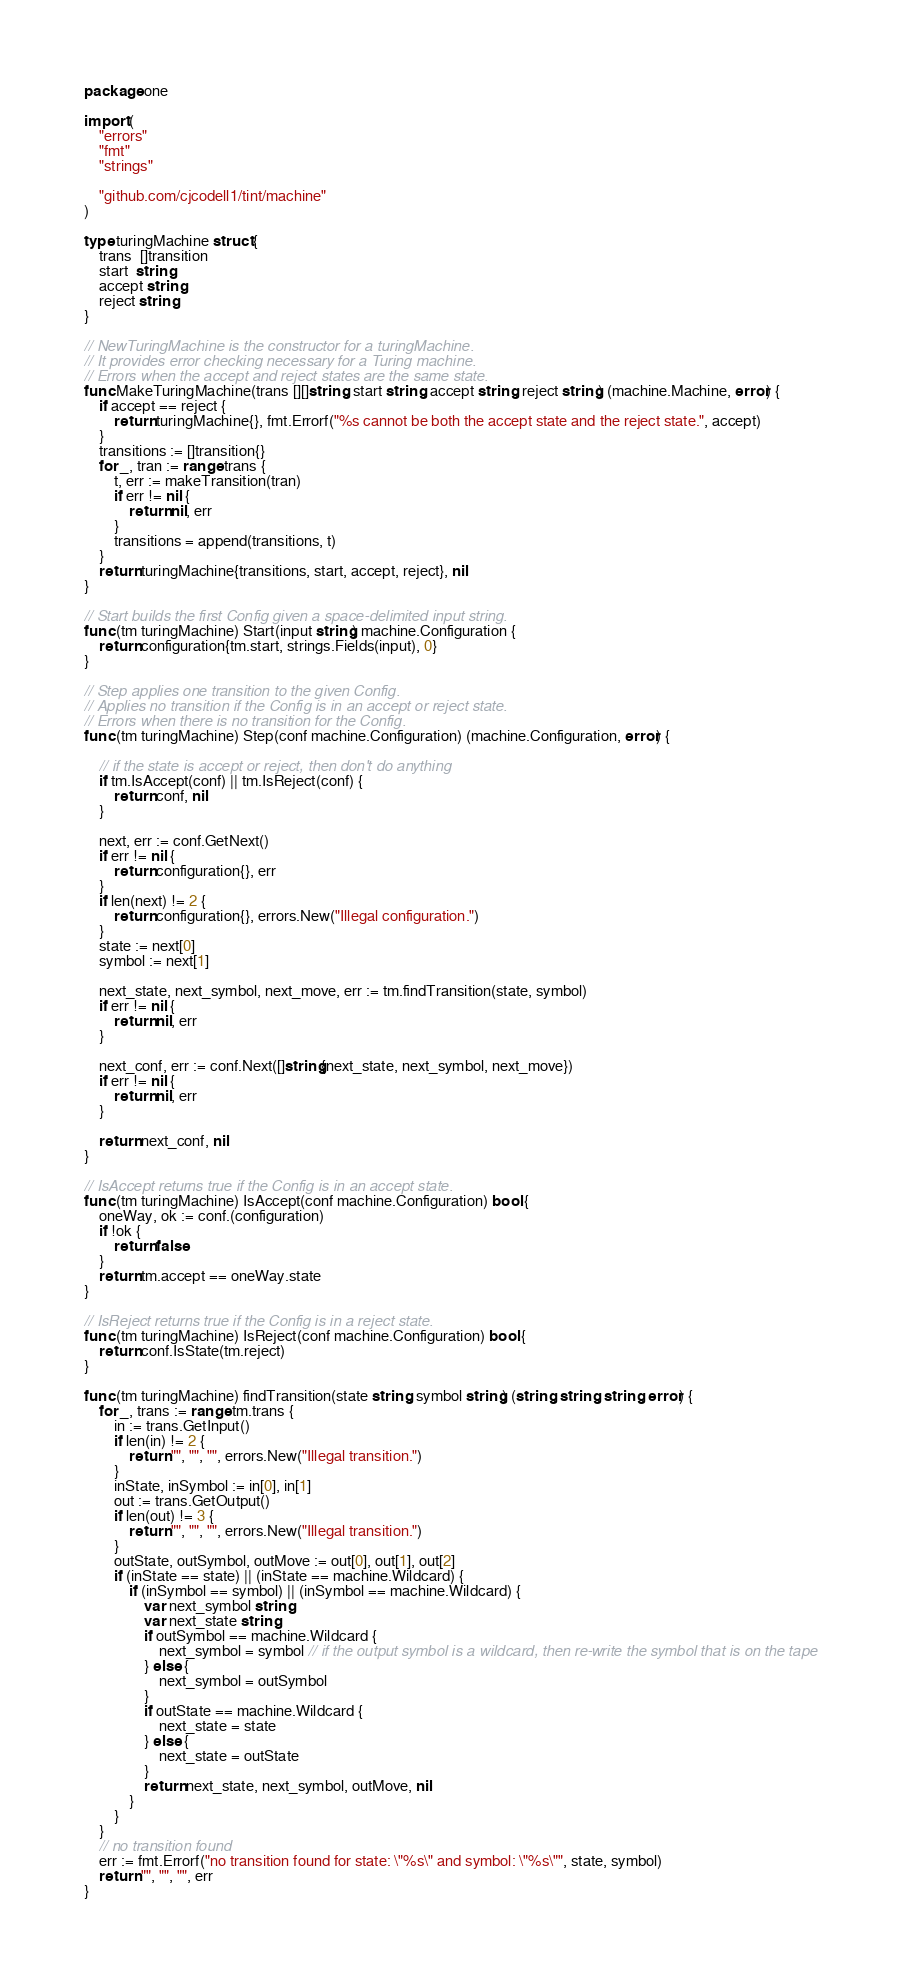Convert code to text. <code><loc_0><loc_0><loc_500><loc_500><_Go_>package one

import (
	"errors"
	"fmt"
	"strings"

	"github.com/cjcodell1/tint/machine"
)

type turingMachine struct {
	trans  []transition
	start  string
	accept string
	reject string
}

// NewTuringMachine is the constructor for a turingMachine.
// It provides error checking necessary for a Turing machine.
// Errors when the accept and reject states are the same state.
func MakeTuringMachine(trans [][]string, start string, accept string, reject string) (machine.Machine, error) {
	if accept == reject {
		return turingMachine{}, fmt.Errorf("%s cannot be both the accept state and the reject state.", accept)
	}
	transitions := []transition{}
	for _, tran := range trans {
		t, err := makeTransition(tran)
		if err != nil {
			return nil, err
		}
		transitions = append(transitions, t)
	}
	return turingMachine{transitions, start, accept, reject}, nil
}

// Start builds the first Config given a space-delimited input string.
func (tm turingMachine) Start(input string) machine.Configuration {
	return configuration{tm.start, strings.Fields(input), 0}
}

// Step applies one transition to the given Config.
// Applies no transition if the Config is in an accept or reject state.
// Errors when there is no transition for the Config.
func (tm turingMachine) Step(conf machine.Configuration) (machine.Configuration, error) {

	// if the state is accept or reject, then don't do anything
	if tm.IsAccept(conf) || tm.IsReject(conf) {
		return conf, nil
	}

	next, err := conf.GetNext()
	if err != nil {
		return configuration{}, err
	}
	if len(next) != 2 {
		return configuration{}, errors.New("Illegal configuration.")
	}
	state := next[0]
	symbol := next[1]

	next_state, next_symbol, next_move, err := tm.findTransition(state, symbol)
	if err != nil {
		return nil, err
	}

	next_conf, err := conf.Next([]string{next_state, next_symbol, next_move})
	if err != nil {
		return nil, err
	}

	return next_conf, nil
}

// IsAccept returns true if the Config is in an accept state.
func (tm turingMachine) IsAccept(conf machine.Configuration) bool {
	oneWay, ok := conf.(configuration)
	if !ok {
		return false
	}
	return tm.accept == oneWay.state
}

// IsReject returns true if the Config is in a reject state.
func (tm turingMachine) IsReject(conf machine.Configuration) bool {
	return conf.IsState(tm.reject)
}

func (tm turingMachine) findTransition(state string, symbol string) (string, string, string, error) {
	for _, trans := range tm.trans {
		in := trans.GetInput()
		if len(in) != 2 {
			return "", "", "", errors.New("Illegal transition.")
		}
		inState, inSymbol := in[0], in[1]
		out := trans.GetOutput()
		if len(out) != 3 {
			return "", "", "", errors.New("Illegal transition.")
		}
		outState, outSymbol, outMove := out[0], out[1], out[2]
		if (inState == state) || (inState == machine.Wildcard) {
			if (inSymbol == symbol) || (inSymbol == machine.Wildcard) {
				var next_symbol string
				var next_state string
				if outSymbol == machine.Wildcard {
					next_symbol = symbol // if the output symbol is a wildcard, then re-write the symbol that is on the tape
				} else {
					next_symbol = outSymbol
				}
				if outState == machine.Wildcard {
					next_state = state
				} else {
					next_state = outState
				}
				return next_state, next_symbol, outMove, nil
			}
		}
	}
	// no transition found
	err := fmt.Errorf("no transition found for state: \"%s\" and symbol: \"%s\"", state, symbol)
	return "", "", "", err
}
</code> 